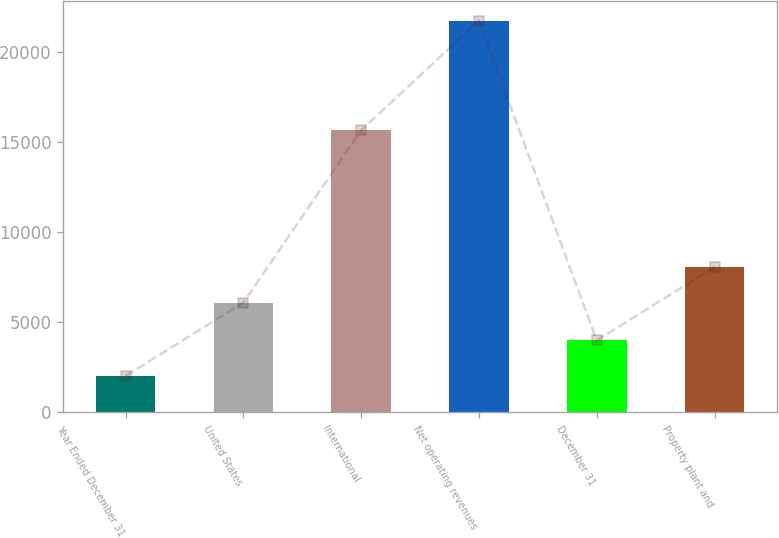<chart> <loc_0><loc_0><loc_500><loc_500><bar_chart><fcel>Year Ended December 31<fcel>United States<fcel>International<fcel>Net operating revenues<fcel>December 31<fcel>Property plant and<nl><fcel>2004<fcel>6084<fcel>15658<fcel>21742<fcel>3977.8<fcel>8057.8<nl></chart> 